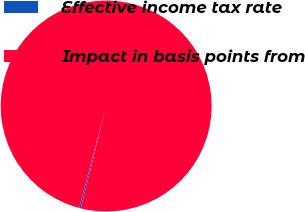Convert chart. <chart><loc_0><loc_0><loc_500><loc_500><pie_chart><fcel>Effective income tax rate<fcel>Impact in basis points from<nl><fcel>0.25%<fcel>99.75%<nl></chart> 